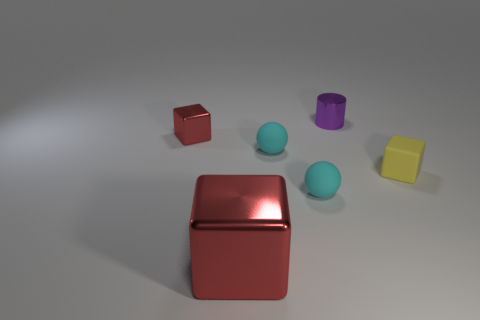What number of other objects are the same color as the small metal block?
Provide a short and direct response. 1. There is a thing that is both in front of the small yellow matte object and to the right of the big red block; what is its color?
Make the answer very short. Cyan. How big is the metal block that is in front of the red metallic thing behind the small rubber object that is behind the small yellow cube?
Your response must be concise. Large. How many things are either things in front of the small red shiny block or objects to the right of the tiny purple shiny cylinder?
Offer a very short reply. 4. What shape is the small purple thing?
Your answer should be very brief. Cylinder. How many other things are there of the same material as the big red cube?
Your answer should be compact. 2. There is another rubber thing that is the same shape as the big object; what size is it?
Ensure brevity in your answer.  Small. What material is the tiny cyan thing that is behind the tiny rubber ball that is in front of the yellow matte thing right of the small purple shiny thing made of?
Your answer should be very brief. Rubber. Is there a blue matte cylinder?
Your answer should be compact. No. There is a big cube; is its color the same as the matte thing to the right of the metallic cylinder?
Offer a terse response. No. 